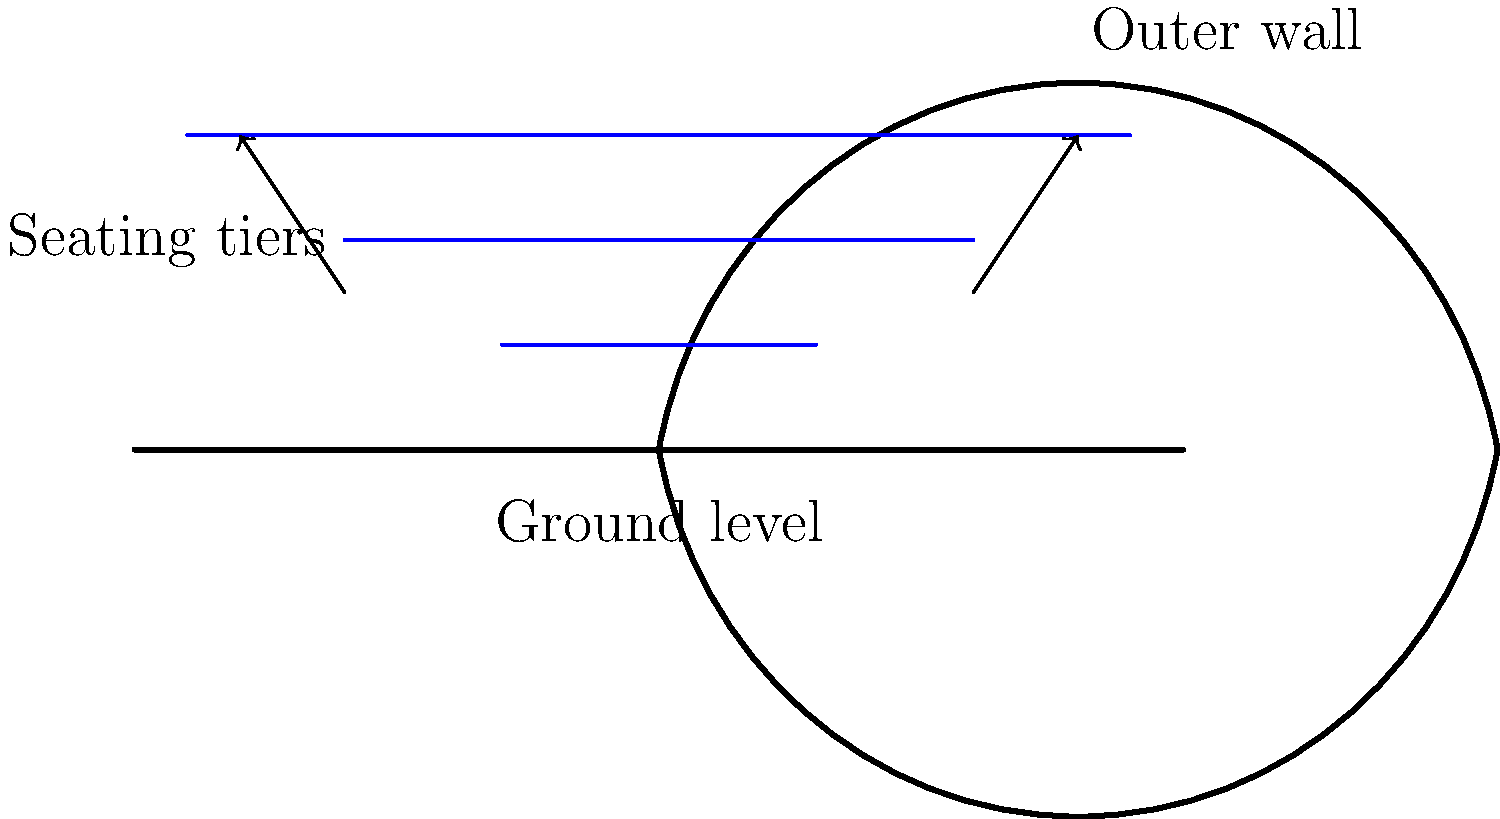Considering the engineering principles behind the Colosseum's seating arrangements, how did the Romans ensure optimal visibility for spectators while maintaining structural integrity? Refer to the cross-section diagram provided. The Romans employed several engineering principles to ensure optimal visibility and structural integrity in the Colosseum's seating arrangements:

1. Tiered seating: The diagram shows three distinct tiers of seating. This design allowed for a steep incline, ensuring that spectators in higher rows could see over those in front of them.

2. Elliptical shape: Although not visible in this cross-section, the Colosseum's elliptical shape brought spectators closer to the action, improving visibility from all angles.

3. Vaulted substructures: The curved lines beneath the seating tiers represent vaulted substructures. These distributed the weight of the upper tiers and spectators efficiently, ensuring structural stability.

4. Sloped seating: Each tier is angled upwards, further improving the line of sight for spectators.

5. Proportional design: The height and depth of each seating tier were carefully calculated to provide optimal viewing angles while maintaining structural balance.

6. Outer wall support: The tall outer wall, clearly visible in the diagram, provided crucial support for the entire structure, allowing for the height necessary to accommodate large numbers of spectators.

7. Materials used: While not shown in the diagram, the Romans used a combination of travertine, tuff, and brick-faced concrete, each chosen for its specific properties to enhance structural integrity.

These engineering principles allowed the Romans to create a massive yet stable structure that could seat approximately 50,000 spectators with good visibility of the arena floor.
Answer: Tiered, sloped seating with vaulted substructures and a supportive outer wall 